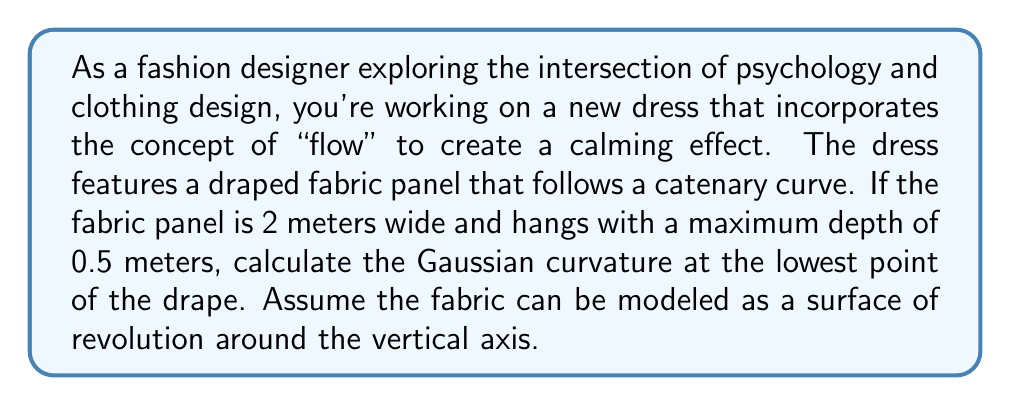Provide a solution to this math problem. To solve this problem, we'll follow these steps:

1) First, recall that a catenary curve is described by the equation:

   $$y = a \cosh(\frac{x}{a})$$

   where $a$ is a constant that determines the shape of the curve.

2) Given that the width is 2 meters and the maximum depth is 0.5 meters, we can determine the value of $a$:

   $$0.5 = a (\cosh(1/a) - 1)$$

   This equation can be solved numerically to find $a \approx 1.1243$.

3) Now, we can represent our surface of revolution parametrically:

   $$r(u,v) = (u, a \cosh(\frac{v}{a}), v)$$

   where $-1 \leq u \leq 1$ and $-1 \leq v \leq 1$.

4) To calculate the Gaussian curvature, we need to find the first and second fundamental forms. The partial derivatives are:

   $$r_u = (1, 0, 0)$$
   $$r_v = (0, \sinh(\frac{v}{a}), 1)$$
   $$r_{uu} = (0, 0, 0)$$
   $$r_{uv} = (0, 0, 0)$$
   $$r_{vv} = (0, \frac{1}{a}\cosh(\frac{v}{a}), 0)$$

5) The coefficients of the first fundamental form are:

   $$E = 1, F = 0, G = \sinh^2(\frac{v}{a}) + 1$$

6) The coefficients of the second fundamental form are:

   $$L = 0, M = 0, N = \frac{\cosh(\frac{v}{a})}{\sqrt{\sinh^2(\frac{v}{a}) + 1}}$$

7) The Gaussian curvature is given by:

   $$K = \frac{LN - M^2}{EG - F^2}$$

8) At the lowest point of the drape, $v = 0$, so:

   $$K = \frac{0 \cdot \frac{1}{\sqrt{1}} - 0^2}{1 \cdot 1 - 0^2} = 0$$

Therefore, the Gaussian curvature at the lowest point of the drape is 0.
Answer: The Gaussian curvature at the lowest point of the draped fabric panel is 0. 